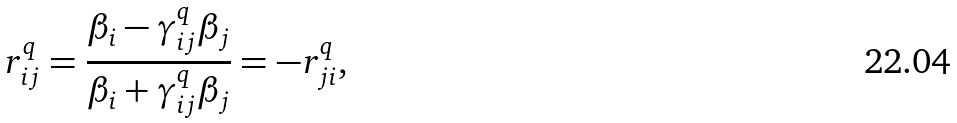Convert formula to latex. <formula><loc_0><loc_0><loc_500><loc_500>r ^ { q } _ { i j } = \frac { \beta _ { i } - \gamma ^ { q } _ { i j } \beta _ { j } } { \beta _ { i } + \gamma ^ { q } _ { i j } \beta _ { j } } = - r ^ { q } _ { j i } ,</formula> 